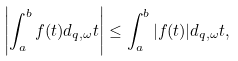Convert formula to latex. <formula><loc_0><loc_0><loc_500><loc_500>\left | \int _ { a } ^ { b } f ( t ) d _ { q , \omega } t \right | \leq \int _ { a } ^ { b } | f ( t ) | d _ { q , \omega } t ,</formula> 